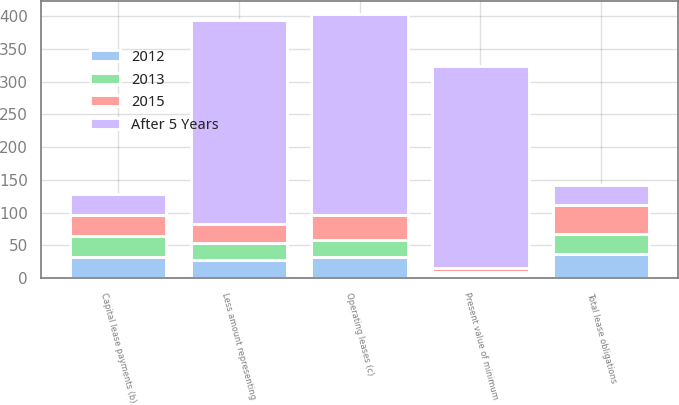Convert chart. <chart><loc_0><loc_0><loc_500><loc_500><stacked_bar_chart><ecel><fcel>Capital lease payments (b)<fcel>Less amount representing<fcel>Present value of minimum<fcel>Operating leases (c)<fcel>Total lease obligations<nl><fcel>After 5 Years<fcel>32<fcel>312<fcel>309<fcel>307<fcel>32<nl><fcel>2015<fcel>33<fcel>28<fcel>5<fcel>38<fcel>43<nl><fcel>2012<fcel>32<fcel>27<fcel>5<fcel>32<fcel>37<nl><fcel>2013<fcel>32<fcel>27<fcel>5<fcel>26<fcel>31<nl></chart> 